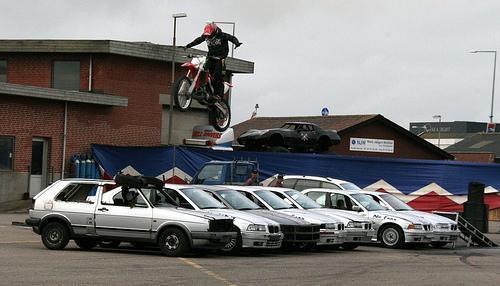How many cars are in the front?
Give a very brief answer. 7. 